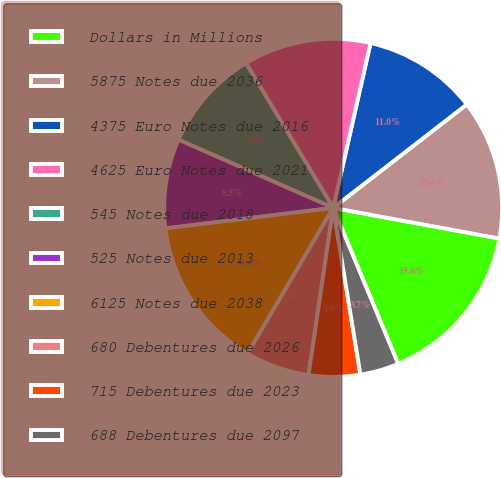Convert chart to OTSL. <chart><loc_0><loc_0><loc_500><loc_500><pie_chart><fcel>Dollars in Millions<fcel>5875 Notes due 2036<fcel>4375 Euro Notes due 2016<fcel>4625 Euro Notes due 2021<fcel>545 Notes due 2018<fcel>525 Notes due 2013<fcel>6125 Notes due 2038<fcel>680 Debentures due 2026<fcel>715 Debentures due 2023<fcel>688 Debentures due 2097<nl><fcel>15.82%<fcel>13.39%<fcel>10.97%<fcel>12.18%<fcel>9.76%<fcel>8.55%<fcel>14.61%<fcel>6.12%<fcel>4.91%<fcel>3.7%<nl></chart> 